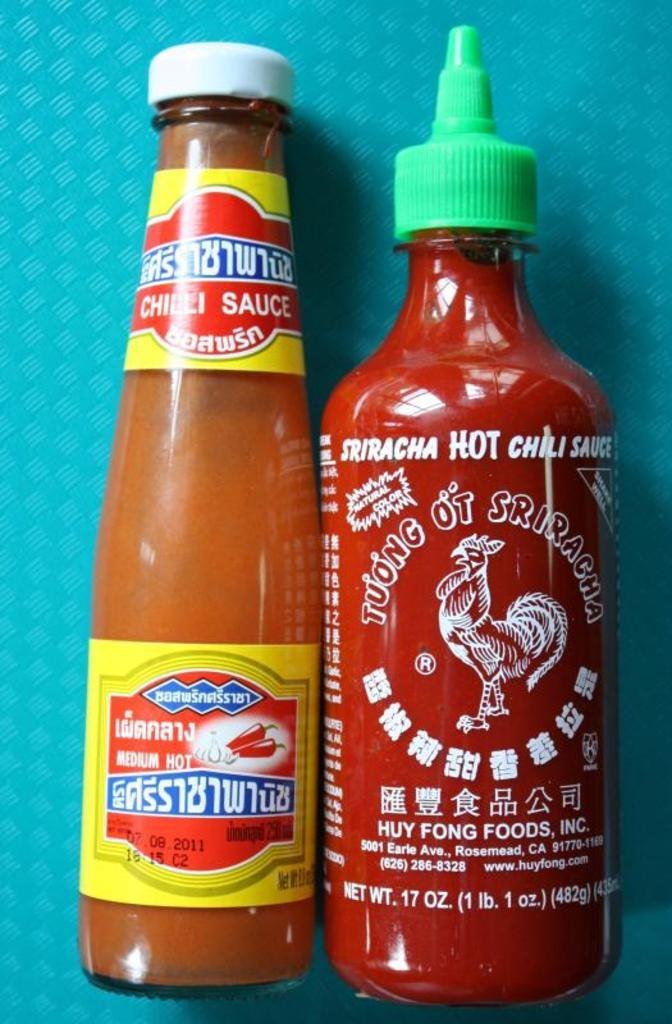<image>
Share a concise interpretation of the image provided. A bottle of hot chili sauce is next to a medium chili sauce bottle. 